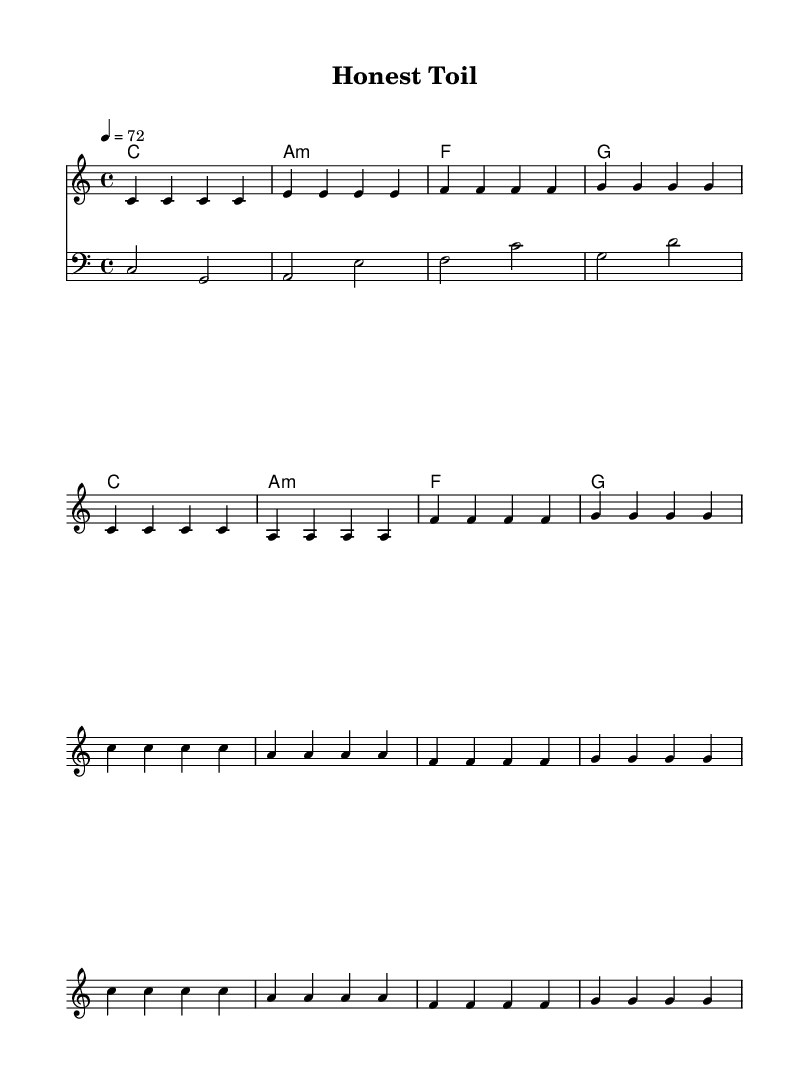What is the key signature of this music? The key signature is C major, which has no sharps or flats.
Answer: C major What is the time signature of this music? The time signature is indicated as 4/4 at the beginning of the score.
Answer: 4/4 What is the tempo marking for this piece? The tempo marking is given as 4 equals 72, indicating the speed of the music.
Answer: 72 How many measures are in the verse section? The verse consists of 8 measures total based on the provided melody notation.
Answer: 8 measures What are the lyrics emphasizing in the chorus? The chorus focuses on dignity in labor and pride in hard work, suggesting the song’s theme of valuing honest labor.
Answer: Dignity in labor Which instrument plays the bass line? The bass line is indicated using the bass clef, showing that it is written for a bass instrument.
Answer: Bass How does this reggae piece reflect the genre’s themes? The song celebrates the dignity of labor with a strong rhythmic feel and lyrics emphasizing hard work and familial dedication, common in roots reggae.
Answer: Roots reggae themes 